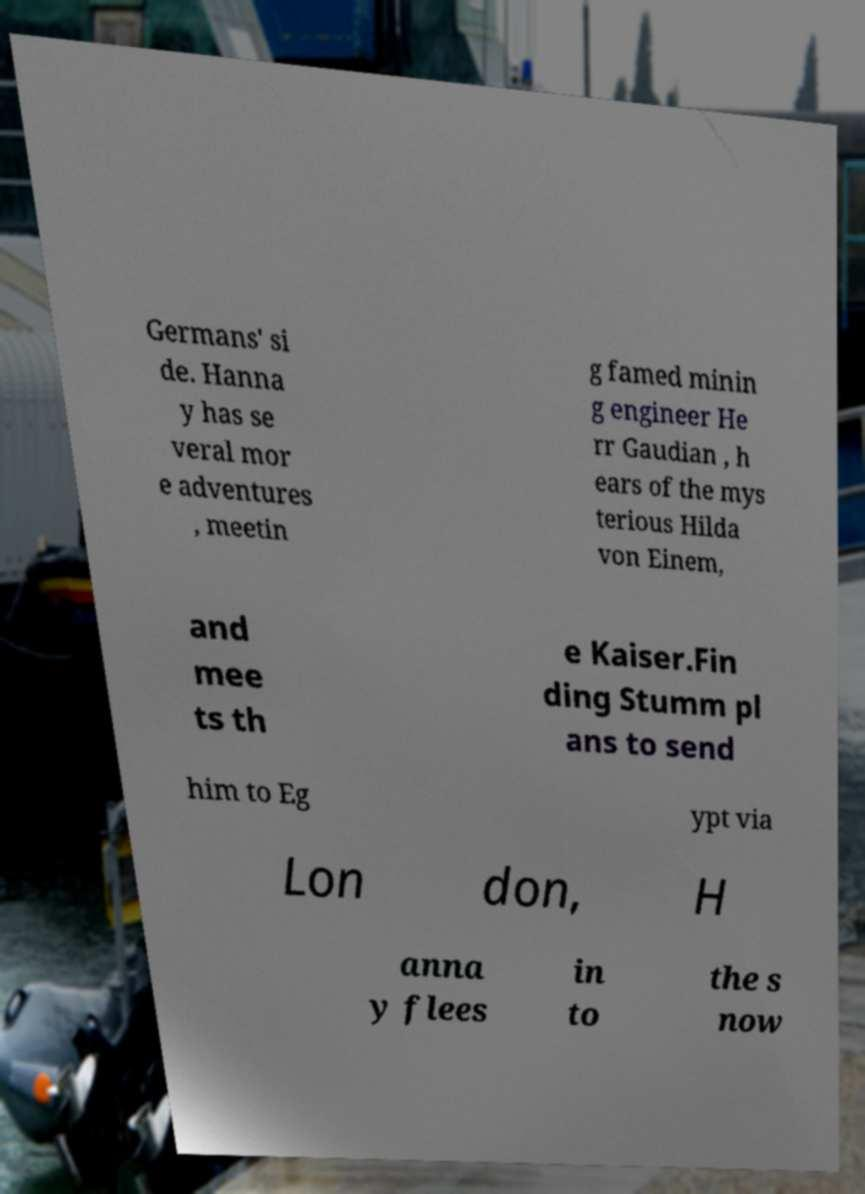Can you read and provide the text displayed in the image?This photo seems to have some interesting text. Can you extract and type it out for me? Germans' si de. Hanna y has se veral mor e adventures , meetin g famed minin g engineer He rr Gaudian , h ears of the mys terious Hilda von Einem, and mee ts th e Kaiser.Fin ding Stumm pl ans to send him to Eg ypt via Lon don, H anna y flees in to the s now 